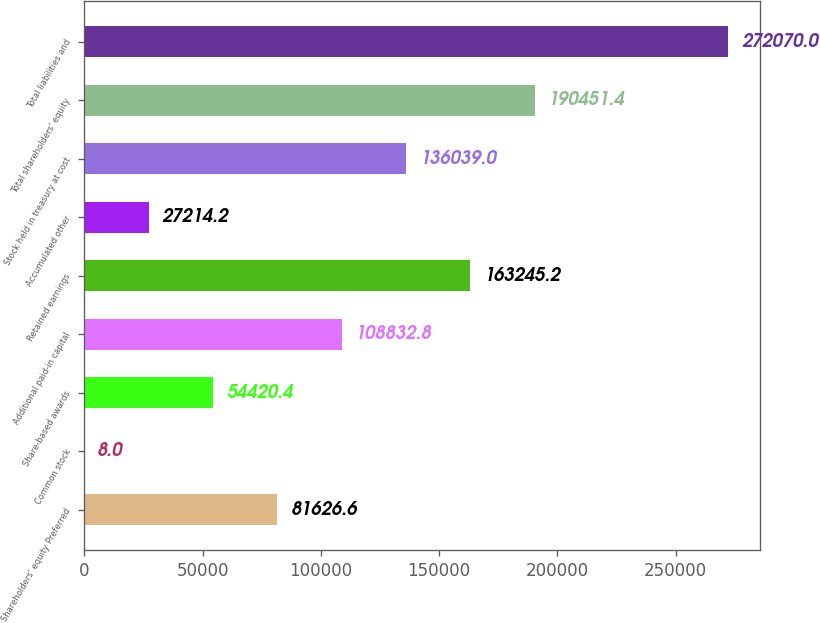<chart> <loc_0><loc_0><loc_500><loc_500><bar_chart><fcel>Shareholders' equity Preferred<fcel>Common stock<fcel>Share-based awards<fcel>Additional paid-in capital<fcel>Retained earnings<fcel>Accumulated other<fcel>Stock held in treasury at cost<fcel>Total shareholders' equity<fcel>Total liabilities and<nl><fcel>81626.6<fcel>8<fcel>54420.4<fcel>108833<fcel>163245<fcel>27214.2<fcel>136039<fcel>190451<fcel>272070<nl></chart> 